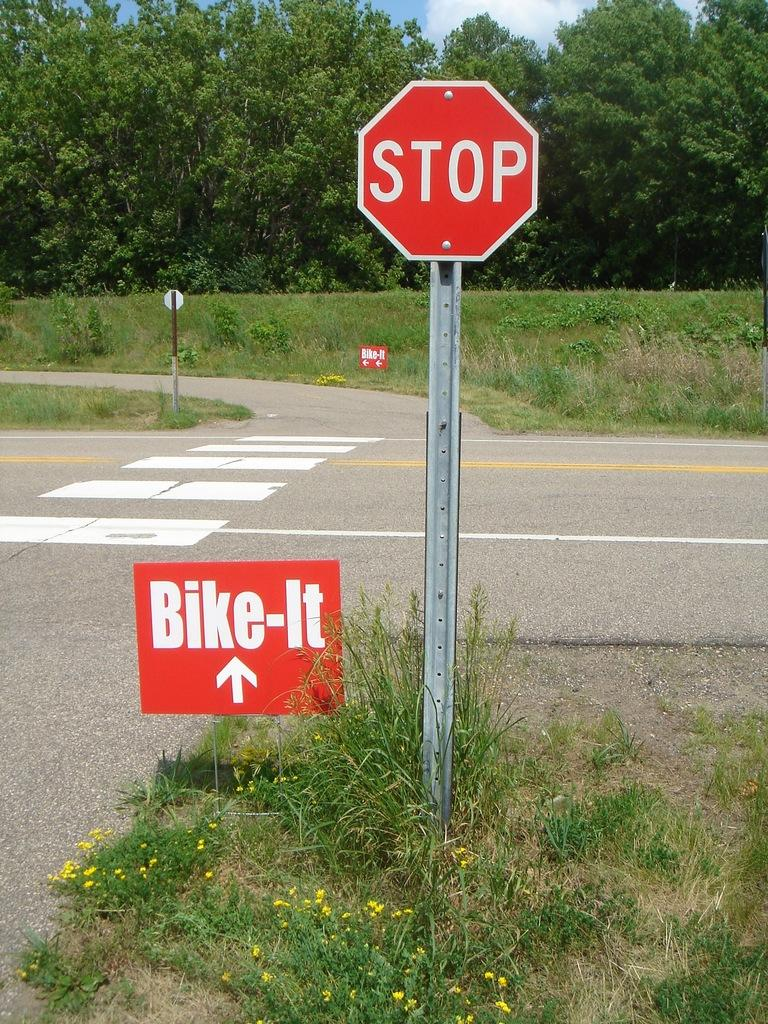Provide a one-sentence caption for the provided image. A red stop sign and on the bottom ground a red Bike it sign. 